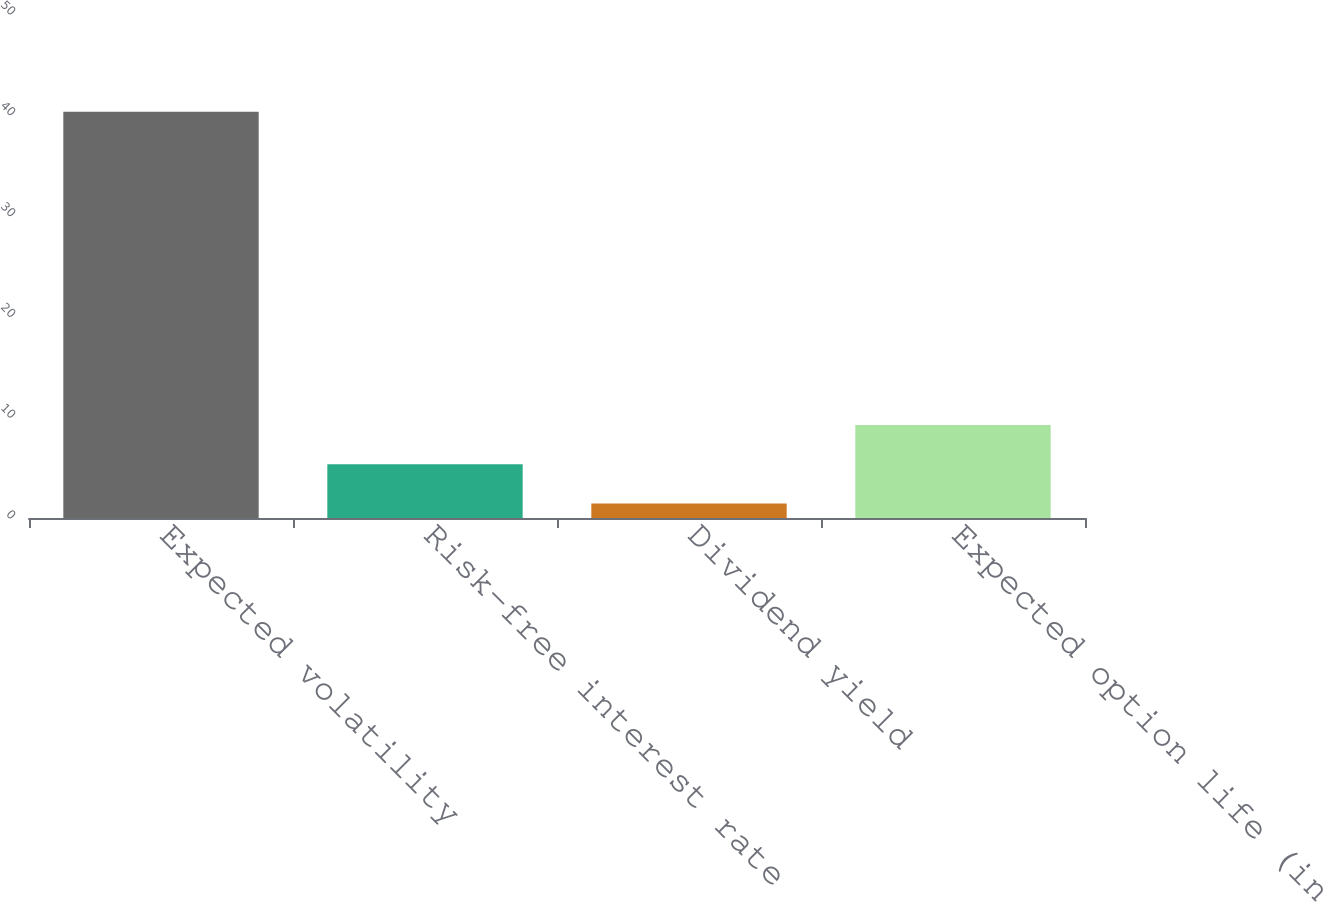Convert chart. <chart><loc_0><loc_0><loc_500><loc_500><bar_chart><fcel>Expected volatility<fcel>Risk-free interest rate<fcel>Dividend yield<fcel>Expected option life (in<nl><fcel>40.31<fcel>5.33<fcel>1.44<fcel>9.22<nl></chart> 